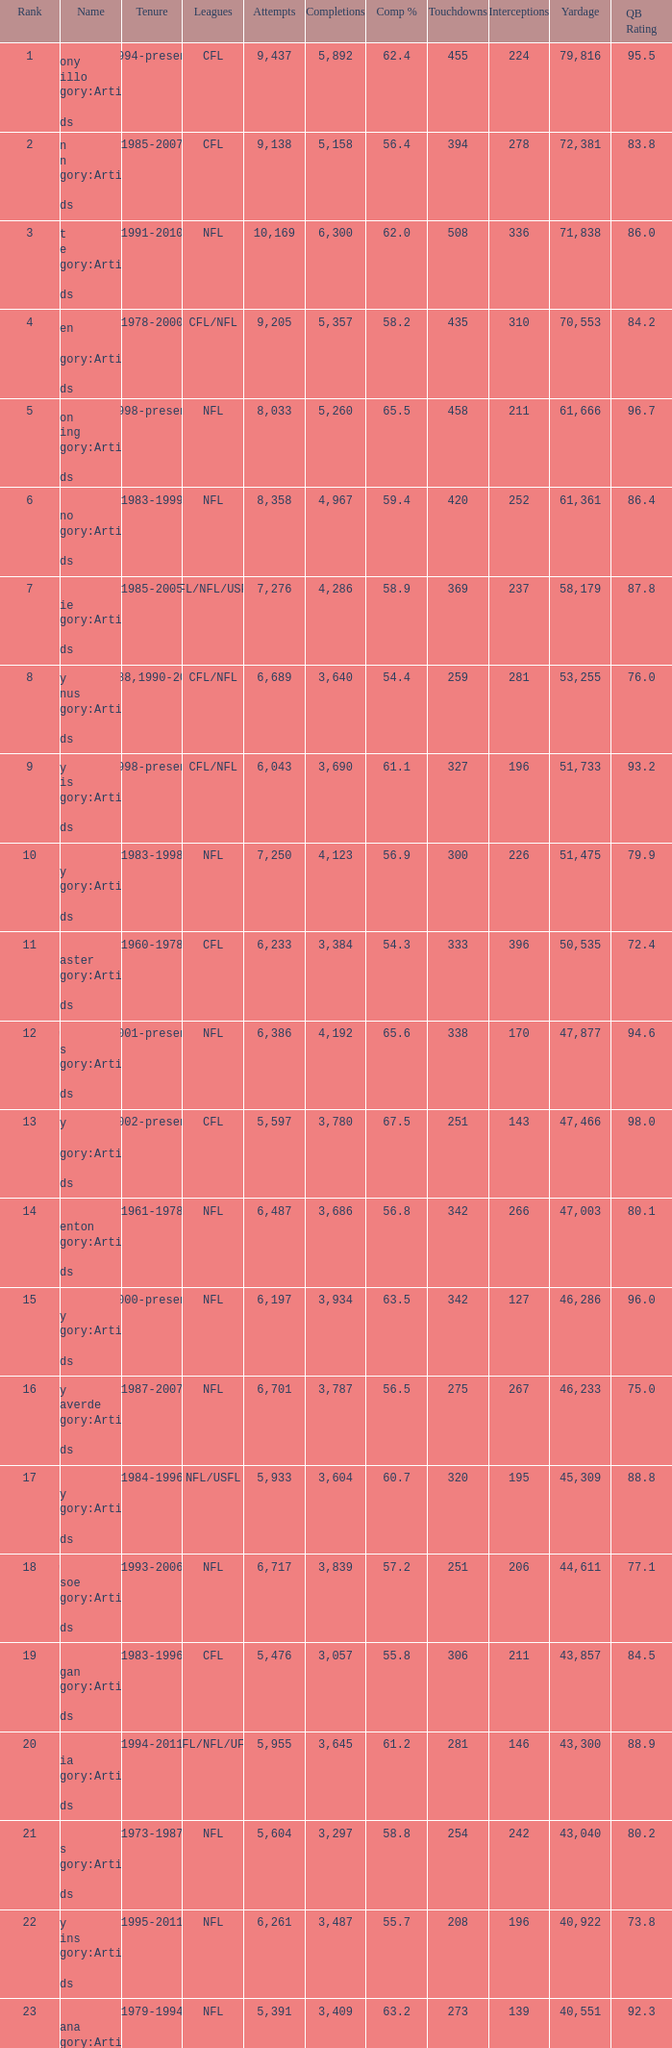What is the completion percentage when the yardage is under 44,611, there are over 254 touchdowns, and the rank is above 24? 54.6. Give me the full table as a dictionary. {'header': ['Rank', 'Name', 'Tenure', 'Leagues', 'Attempts', 'Completions', 'Comp %', 'Touchdowns', 'Interceptions', 'Yardage', 'QB Rating'], 'rows': [['1', 'Anthony Calvillo Category:Articles with hCards', '1994-present', 'CFL', '9,437', '5,892', '62.4', '455', '224', '79,816', '95.5'], ['2', 'Damon Allen Category:Articles with hCards', '1985-2007', 'CFL', '9,138', '5,158', '56.4', '394', '278', '72,381', '83.8'], ['3', 'Brett Favre Category:Articles with hCards', '1991-2010', 'NFL', '10,169', '6,300', '62.0', '508', '336', '71,838', '86.0'], ['4', 'Warren Moon Category:Articles with hCards', '1978-2000', 'CFL/NFL', '9,205', '5,357', '58.2', '435', '310', '70,553', '84.2'], ['5', 'Peyton Manning Category:Articles with hCards', '1998-present', 'NFL', '8,033', '5,260', '65.5', '458', '211', '61,666', '96.7'], ['6', 'Dan Marino Category:Articles with hCards', '1983-1999', 'NFL', '8,358', '4,967', '59.4', '420', '252', '61,361', '86.4'], ['7', 'Doug Flutie Category:Articles with hCards', '1985-2005', 'CFL/NFL/USFL', '7,276', '4,286', '58.9', '369', '237', '58,179', '87.8'], ['8', 'Danny McManus Category:Articles with hCards', '1988,1990-2006', 'CFL/NFL', '6,689', '3,640', '54.4', '259', '281', '53,255', '76.0'], ['9', 'Henry Burris Category:Articles with hCards', '1998-present', 'CFL/NFL', '6,043', '3,690', '61.1', '327', '196', '51,733', '93.2'], ['10', 'John Elway Category:Articles with hCards', '1983-1998', 'NFL', '7,250', '4,123', '56.9', '300', '226', '51,475', '79.9'], ['11', 'Ron Lancaster Category:Articles with hCards', '1960-1978', 'CFL', '6,233', '3,384', '54.3', '333', '396', '50,535', '72.4'], ['12', 'Drew Brees Category:Articles with hCards', '2001-present', 'NFL', '6,386', '4,192', '65.6', '338', '170', '47,877', '94.6'], ['13', 'Ricky Ray Category:Articles with hCards', '2002-present', 'CFL', '5,597', '3,780', '67.5', '251', '143', '47,466', '98.0'], ['14', 'Fran Tarkenton Category:Articles with hCards', '1961-1978', 'NFL', '6,487', '3,686', '56.8', '342', '266', '47,003', '80.1'], ['15', 'Tom Brady Category:Articles with hCards', '2000-present', 'NFL', '6,197', '3,934', '63.5', '342', '127', '46,286', '96.0'], ['16', 'Vinny Testaverde Category:Articles with hCards', '1987-2007', 'NFL', '6,701', '3,787', '56.5', '275', '267', '46,233', '75.0'], ['17', 'Jim Kelly Category:Articles with hCards', '1984-1996', 'NFL/USFL', '5,933', '3,604', '60.7', '320', '195', '45,309', '88.8'], ['18', 'Drew Bledsoe Category:Articles with hCards', '1993-2006', 'NFL', '6,717', '3,839', '57.2', '251', '206', '44,611', '77.1'], ['19', 'Matt Dunigan Category:Articles with hCards', '1983-1996', 'CFL', '5,476', '3,057', '55.8', '306', '211', '43,857', '84.5'], ['20', 'Jeff Garcia Category:Articles with hCards', '1994-2011', 'CFL/NFL/UFL', '5,955', '3,645', '61.2', '281', '146', '43,300', '88.9'], ['21', 'Dan Fouts Category:Articles with hCards', '1973-1987', 'NFL', '5,604', '3,297', '58.8', '254', '242', '43,040', '80.2'], ['22', 'Kerry Collins Category:Articles with hCards', '1995-2011', 'NFL', '6,261', '3,487', '55.7', '208', '196', '40,922', '73.8'], ['23', 'Joe Montana Category:Articles with hCards', '1979-1994', 'NFL', '5,391', '3,409', '63.2', '273', '139', '40,551', '92.3'], ['24', 'Tracy Ham Category:Articles with hCards', '1987-1999', 'CFL', '4,945', '2,670', '54.0', '284', '164', '40,534', '86.6'], ['25', 'Johnny Unitas Category:Articles with hCards', '1956-1973', 'NFL', '5,186', '2,830', '54.6', '290', '253', '40,239', '78.2']]} 